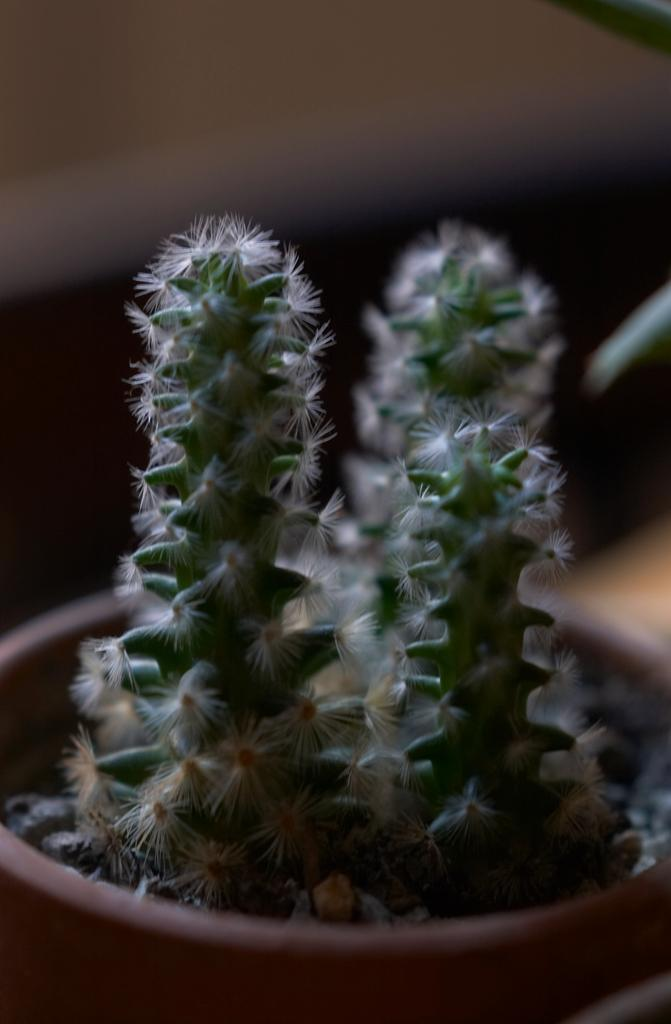What type of living organism is in the image? There is a plant in the image. How is the plant contained or displayed? The plant is in a flower pot. Where is the flower pot located? The flower pot is on a table. How many holes can be seen in the plant's leaves in the image? There are no holes visible in the plant's leaves in the image. What type of knee is supporting the table in the image? There is no knee present in the image, as the table is likely resting on a flat surface. 